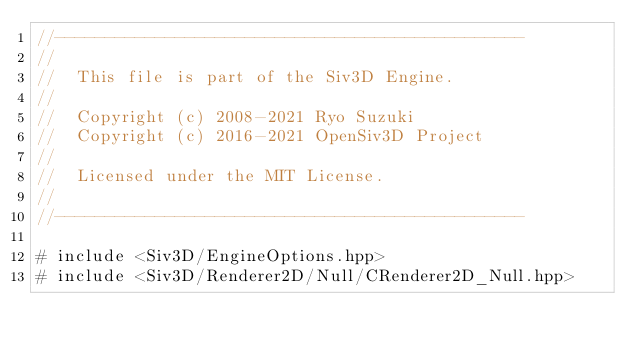<code> <loc_0><loc_0><loc_500><loc_500><_ObjectiveC_>//-----------------------------------------------
//
//	This file is part of the Siv3D Engine.
//
//	Copyright (c) 2008-2021 Ryo Suzuki
//	Copyright (c) 2016-2021 OpenSiv3D Project
//
//	Licensed under the MIT License.
//
//-----------------------------------------------

# include <Siv3D/EngineOptions.hpp>
# include <Siv3D/Renderer2D/Null/CRenderer2D_Null.hpp></code> 